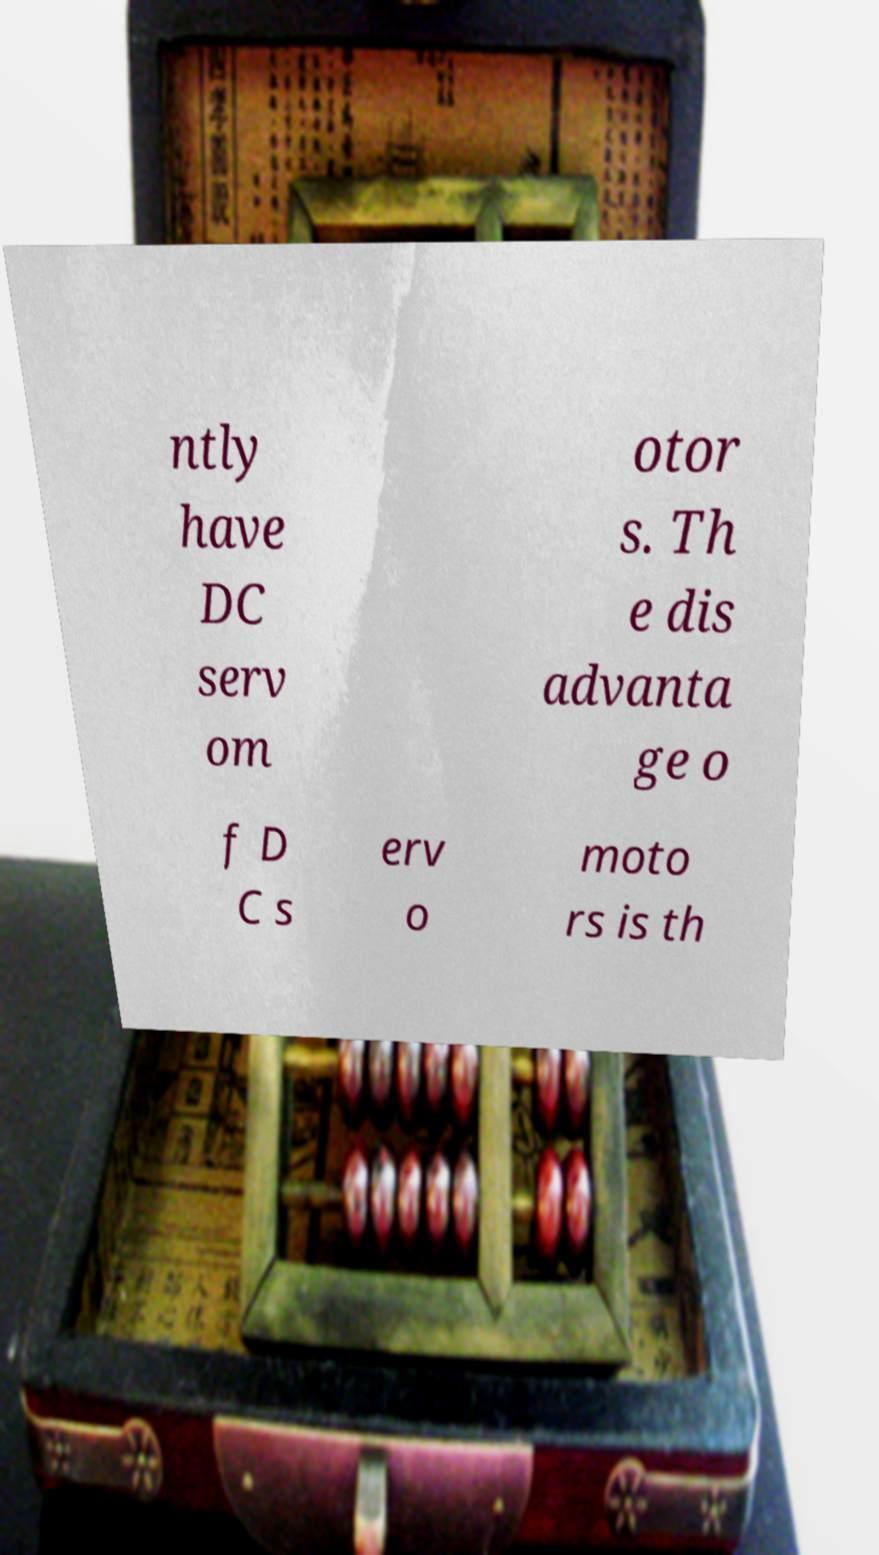Could you assist in decoding the text presented in this image and type it out clearly? ntly have DC serv om otor s. Th e dis advanta ge o f D C s erv o moto rs is th 